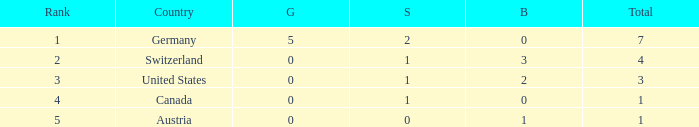What is the total number of bronze when the total is less than 1? None. 